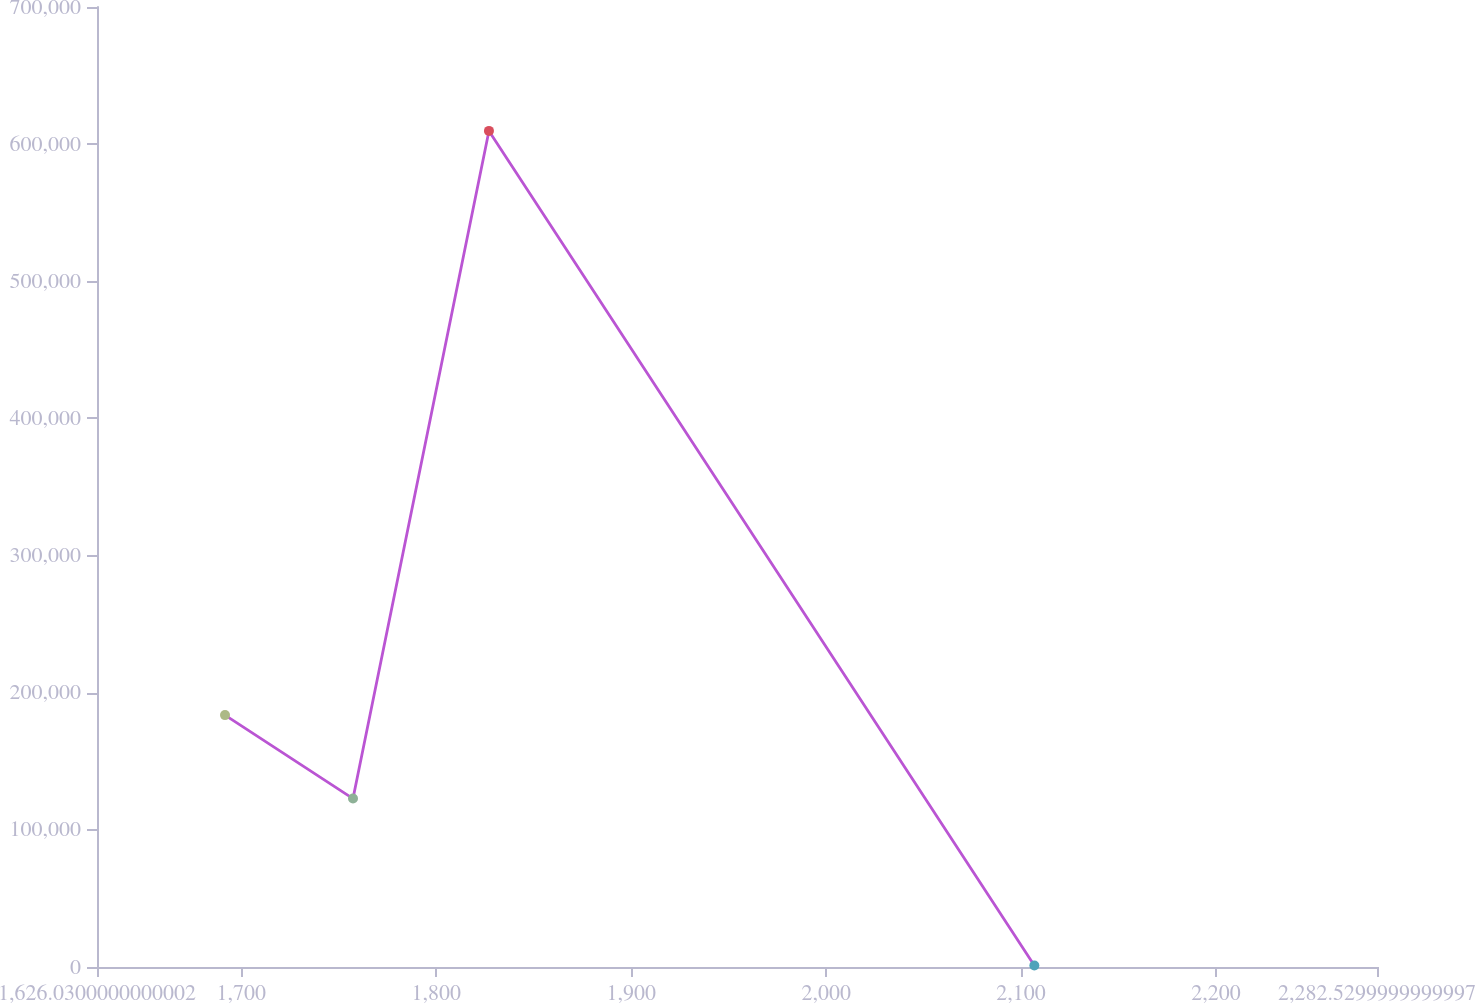Convert chart. <chart><loc_0><loc_0><loc_500><loc_500><line_chart><ecel><fcel>(000s)<nl><fcel>1691.68<fcel>183661<nl><fcel>1757.33<fcel>122805<nl><fcel>1827.06<fcel>609650<nl><fcel>2106.78<fcel>1094.1<nl><fcel>2348.18<fcel>61949.7<nl></chart> 